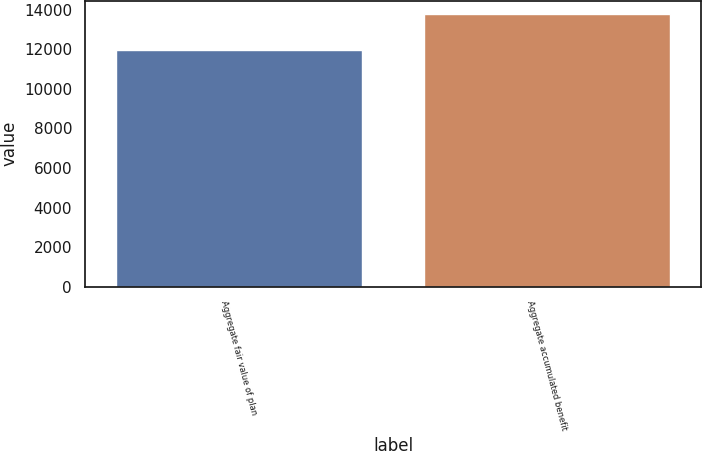Convert chart. <chart><loc_0><loc_0><loc_500><loc_500><bar_chart><fcel>Aggregate fair value of plan<fcel>Aggregate accumulated benefit<nl><fcel>11979<fcel>13755<nl></chart> 